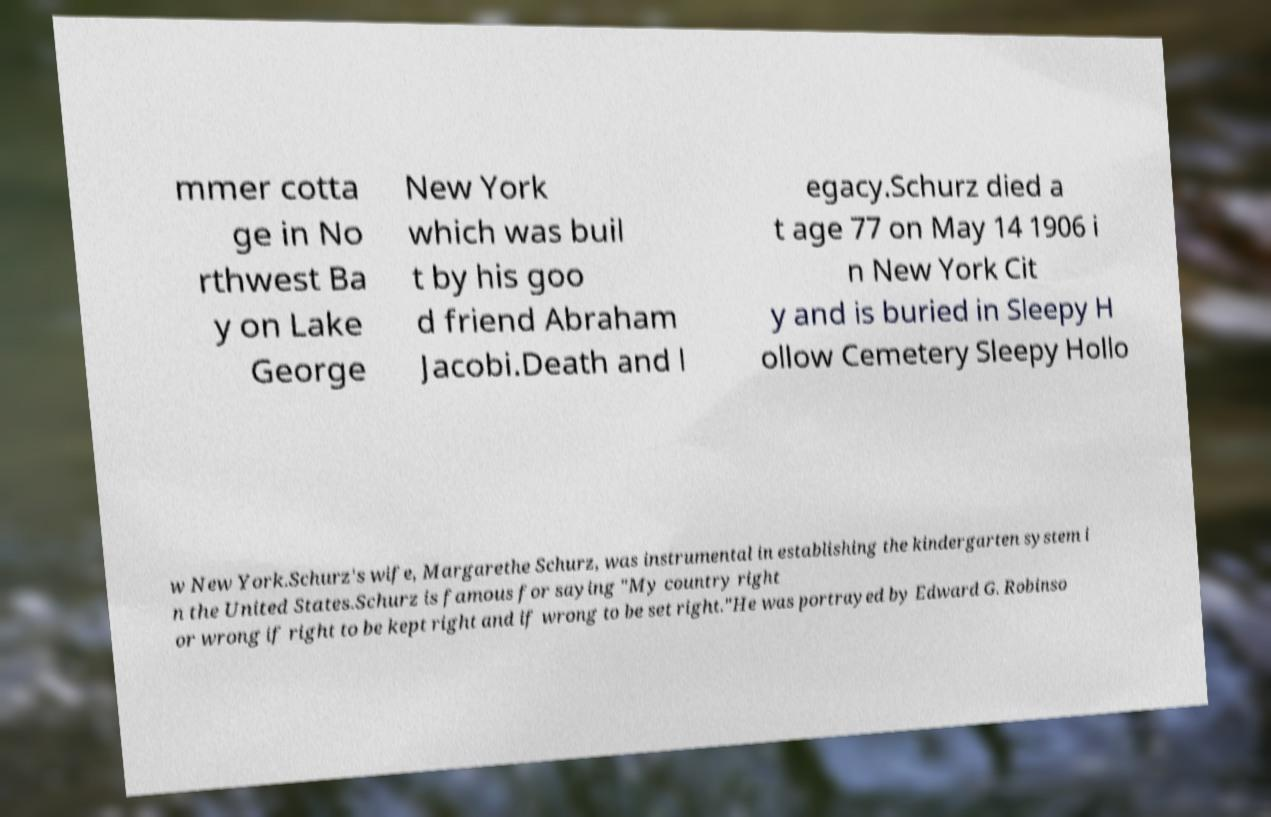For documentation purposes, I need the text within this image transcribed. Could you provide that? mmer cotta ge in No rthwest Ba y on Lake George New York which was buil t by his goo d friend Abraham Jacobi.Death and l egacy.Schurz died a t age 77 on May 14 1906 i n New York Cit y and is buried in Sleepy H ollow Cemetery Sleepy Hollo w New York.Schurz's wife, Margarethe Schurz, was instrumental in establishing the kindergarten system i n the United States.Schurz is famous for saying "My country right or wrong if right to be kept right and if wrong to be set right."He was portrayed by Edward G. Robinso 